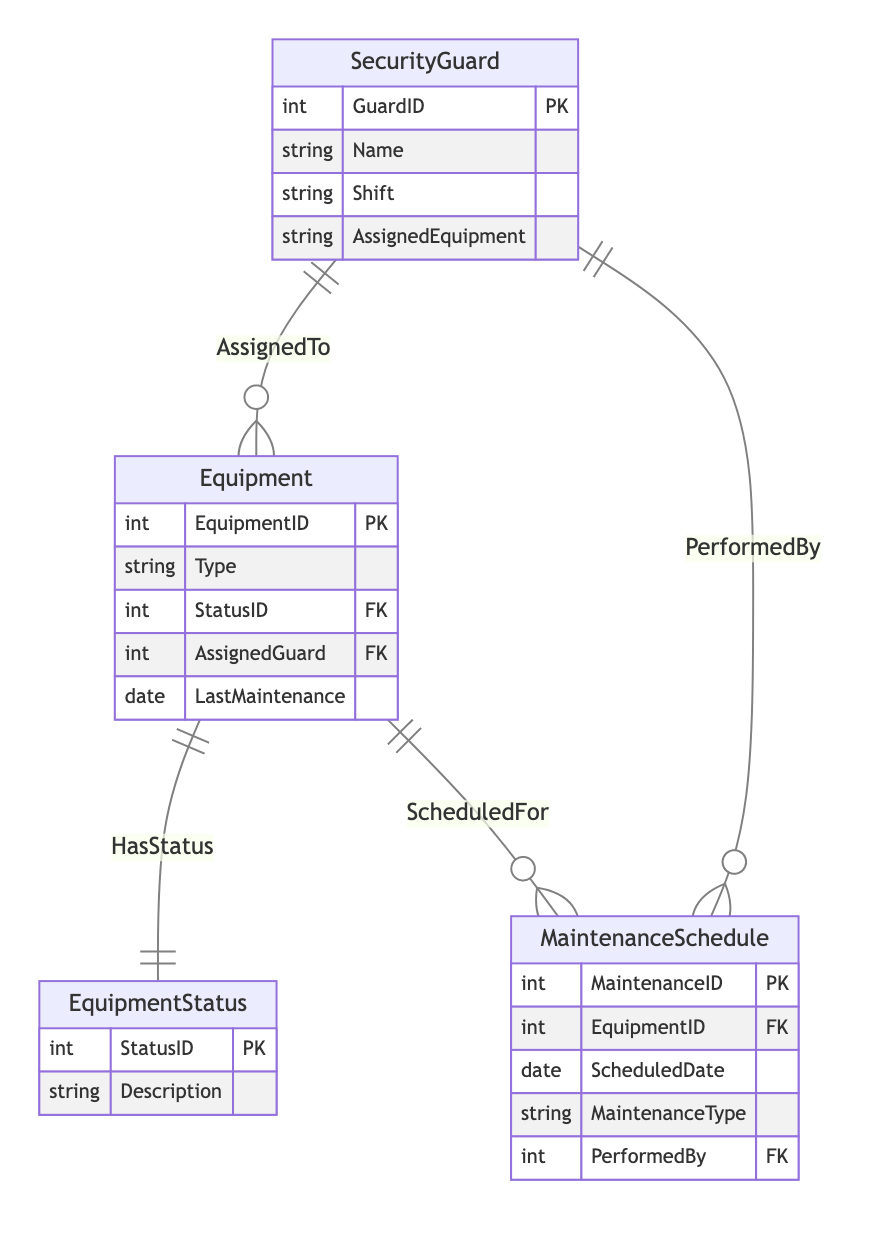What is the primary key of the SecurityGuard entity? The primary key of the SecurityGuard entity is GuardID, which uniquely identifies each security guard in the system.
Answer: GuardID How many entities are represented in the diagram? The diagram contains four entities: SecurityGuard, Equipment, MaintenanceSchedule, and EquipmentStatus, which represent the key components of the equipment inventory management system.
Answer: Four What relationship exists between Equipment and EquipmentStatus? The relationship between Equipment and EquipmentStatus is called "HasStatus," indicating that each piece of equipment has a corresponding status.
Answer: HasStatus What is the maximum number of MaintenanceSchedules that can be associated with a single Equipment? Since each Equipment can have multiple MaintenanceSchedules associated with it through the "ScheduledFor" relationship, there is no specified maximum, allowing potentially many schedules for maintenance.
Answer: Unlimited Which entity includes the MaintenanceType attribute? The MaintenanceSchedule entity includes the MaintenanceType attribute, specifying the type of maintenance scheduled for the equipment.
Answer: MaintenanceSchedule What is the foreign key in the Equipment entity that relates to EquipmentStatus? The foreign key in the Equipment entity that relates to EquipmentStatus is StatusID, establishing a link to the status description for the equipment.
Answer: StatusID How can you identify which guard performed a maintenance task? You can identify the guard who performed a maintenance task by looking at the MaintenanceSchedule entity, which has a foreign key named PerformedBy that references the primary key of the SecurityGuard entity.
Answer: PerformedBy Which entity has an attribute called LastMaintenance? The Equipment entity has an attribute called LastMaintenance, which indicates the date when the equipment was last serviced or maintained.
Answer: Equipment What does the relationship named "AssignedTo" signify? The "AssignedTo" relationship signifies which security guards are assigned specific equipment, connecting the SecurityGuard and Equipment entities through their respective IDs.
Answer: AssignedTo 